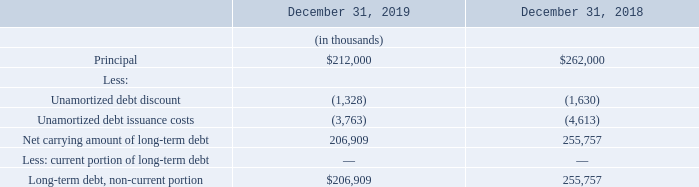8. Debt and Interest Rate Swap
Debt The carrying amount of the Company's long-term debt consists of the following:
On May 12, 2017, the Company entered into a credit agreement with certain lenders and a collateral agent in connection with the acquisition of Exar (Note 3). The credit agreement provides for an initial secured term B loan facility (the “Initial Term Loan”) in an aggregate principal amount of $425.0 million. The credit agreement permits the Company to request incremental loans in an aggregate principal amount not to exceed the sum of $160.0 million (subject to adjustments for any voluntary prepayments), plus an unlimited amount that is subject to pro forma compliance with certain secured leverage ratio and total leverage ratio tests. Incremental loans are subject  to certain additional conditions, including obtaining additional commitments from the lenders then party to the credit agreement or new lenders.
Loans under the credit agreement bear interest, at the Company’s option, at a rate equal to either (i) ab ase rate equal to the highest of (x) the federal funds rate, plus 0.50%, (y) the prime rate then in effect and (z) an adjusted LIBOR rate determined on the basis of a one- three- or six-month interest period, plus 1.0% or (ii) an adjusted LIBOR rate, subject to a floor of 0.75%, in each case, plus an applicable margin of 2.50% in the case of LIBOR rate loans and 1.50% in the case of base rate loans. Commencing on September 30, 2017, the Initial Term Loan will amortize in equal quarterly installments equal to 0.25% of the original principal amount of the Initial Term Loan, with the balance payable on the maturity date. The Initial Term Loan has a term of seven years and will mature on May 12, 2024, at which time all outstanding principal and accrued and unpaid interest on the Initial Term Loan must be repaid. The Company is also required to pay fees customary for a credit facility of this size and type.
The Company is required to make mandatory prepayments of the outstanding principal amount of term loans under the credit agreement with the net cash proceeds from the disposition of certain assets and the receipt of insurance proceeds upon certain casualty and condemnation events, in each case, to the extent not reinvested within a specified time period, from excess cash flow beyond stated threshold amounts, and from the incurrence of certain indebtedness. The Company has the right to prepay its term loans under the credit agreement, in whole or in part, at any time without premium or penalty, subject to certain limitations and a 1.0% soft call premium applicable during the first six months for the loan term. The Company exercised its right to prepay and made aggregate payments of principal of $213.0 million to date through December 31, 2019.
The Company’s obligations under the credit agreement are required to be guaranteed by certain of its domestic subsidiaries meeting materiality thresholds set forth in the credit agreement. Such obligations, including the guaranties, are secured by substantially all of the assets of the Company and the subsidiary guarantors pursuant to a security agreement with the collateral agent.
The credit agreement also contains customary events of default that include, among other things, certain payment defaults, cross defaults to other indebtedness, covenant defaults, change in control defaults, judgment defaults, and bankruptcy and insolvency defaults. If an event of default exists, the lenders may require immediate payment of all obligations under the credit agreement, and may exercise certain other rights and remedies provided for under the credit agreement, the other loan documents and applicable law.
As of December 31, 2019 and 2018, the weighted average effective interest rate on long-term debt was approximately4 .9% and 4.6%, respectively.
The debt is carried at its principal amount, net of unamortized debt discount and issuance costs, and is not adjusted to fair value each period. The issuance date fair value of the liability component of the debt in the amount of $398.5 million was determined using a discounted cash flow analysis, in which the projected interest and principal payments were discounted back to the issuance date of the term loan at a market interest rate for nonconvertible debt of 4.6%, which represents a Level 2 fair value measurement. The debt discount of $2.1 million and debt issuance costs of $6.0 million are being amortized to interest expense using the effective interest method from the issuance date through the contractual maturity date of the term loan of May 12, 2024.
During the year ended December 31, 2017, the Company recognized amortization of debt discount of $0.2 million and debt issuance costs of $0.6 million to interest expense.
The approximate fair value of the term loan as of December 31, 2019 and 2018 was $214.6 million and $268.1 million, respectively, which was estimated on the basis
of inputs that are observable in the market and which is considered a Level 2 measurement method in the fair value hierarchy.
As of December 31, 2019 and 2018, the remaining principal balance on the term loan was $212.0 million and $262.0 million, respectively. The remaining principal
balance is due on May 12, 2024 at the maturity date on the term loan.
What was the Net carrying amount of long-term debt in 2019?
Answer scale should be: thousand. 206,909. What was the Net carrying amount of long-term debt in 2018?
Answer scale should be: thousand. 255,757. What was the principal amount in 2019 and 2018 respectively?
Answer scale should be: thousand. $212,000, $262,000. What was the change in the Principal from 2018 to 2019?
Answer scale should be: thousand. 212,000 - 262,000
Answer: -50000. What is the average Unamortized debt discount for 2018 and 2019?
Answer scale should be: thousand. -(1,328 + 1,630) / 2
Answer: -1479. In which year was Net carrying amount of long-term debt less than 210,000 thousands? Locate and analyze net carrying amount of long-term debt in row 7
answer: 2019. 